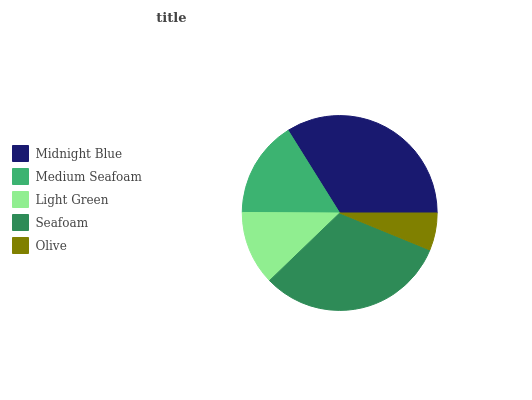Is Olive the minimum?
Answer yes or no. Yes. Is Midnight Blue the maximum?
Answer yes or no. Yes. Is Medium Seafoam the minimum?
Answer yes or no. No. Is Medium Seafoam the maximum?
Answer yes or no. No. Is Midnight Blue greater than Medium Seafoam?
Answer yes or no. Yes. Is Medium Seafoam less than Midnight Blue?
Answer yes or no. Yes. Is Medium Seafoam greater than Midnight Blue?
Answer yes or no. No. Is Midnight Blue less than Medium Seafoam?
Answer yes or no. No. Is Medium Seafoam the high median?
Answer yes or no. Yes. Is Medium Seafoam the low median?
Answer yes or no. Yes. Is Light Green the high median?
Answer yes or no. No. Is Olive the low median?
Answer yes or no. No. 